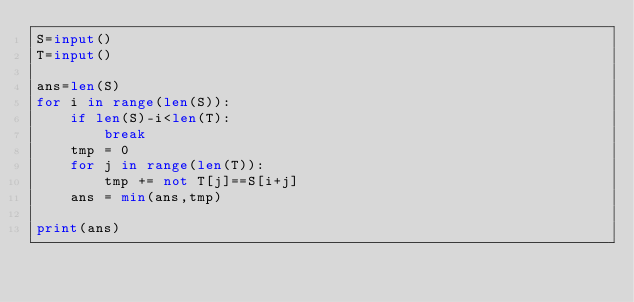Convert code to text. <code><loc_0><loc_0><loc_500><loc_500><_Python_>S=input()
T=input()

ans=len(S)
for i in range(len(S)):
    if len(S)-i<len(T):
        break
    tmp = 0
    for j in range(len(T)):
        tmp += not T[j]==S[i+j]
    ans = min(ans,tmp)

print(ans)
</code> 